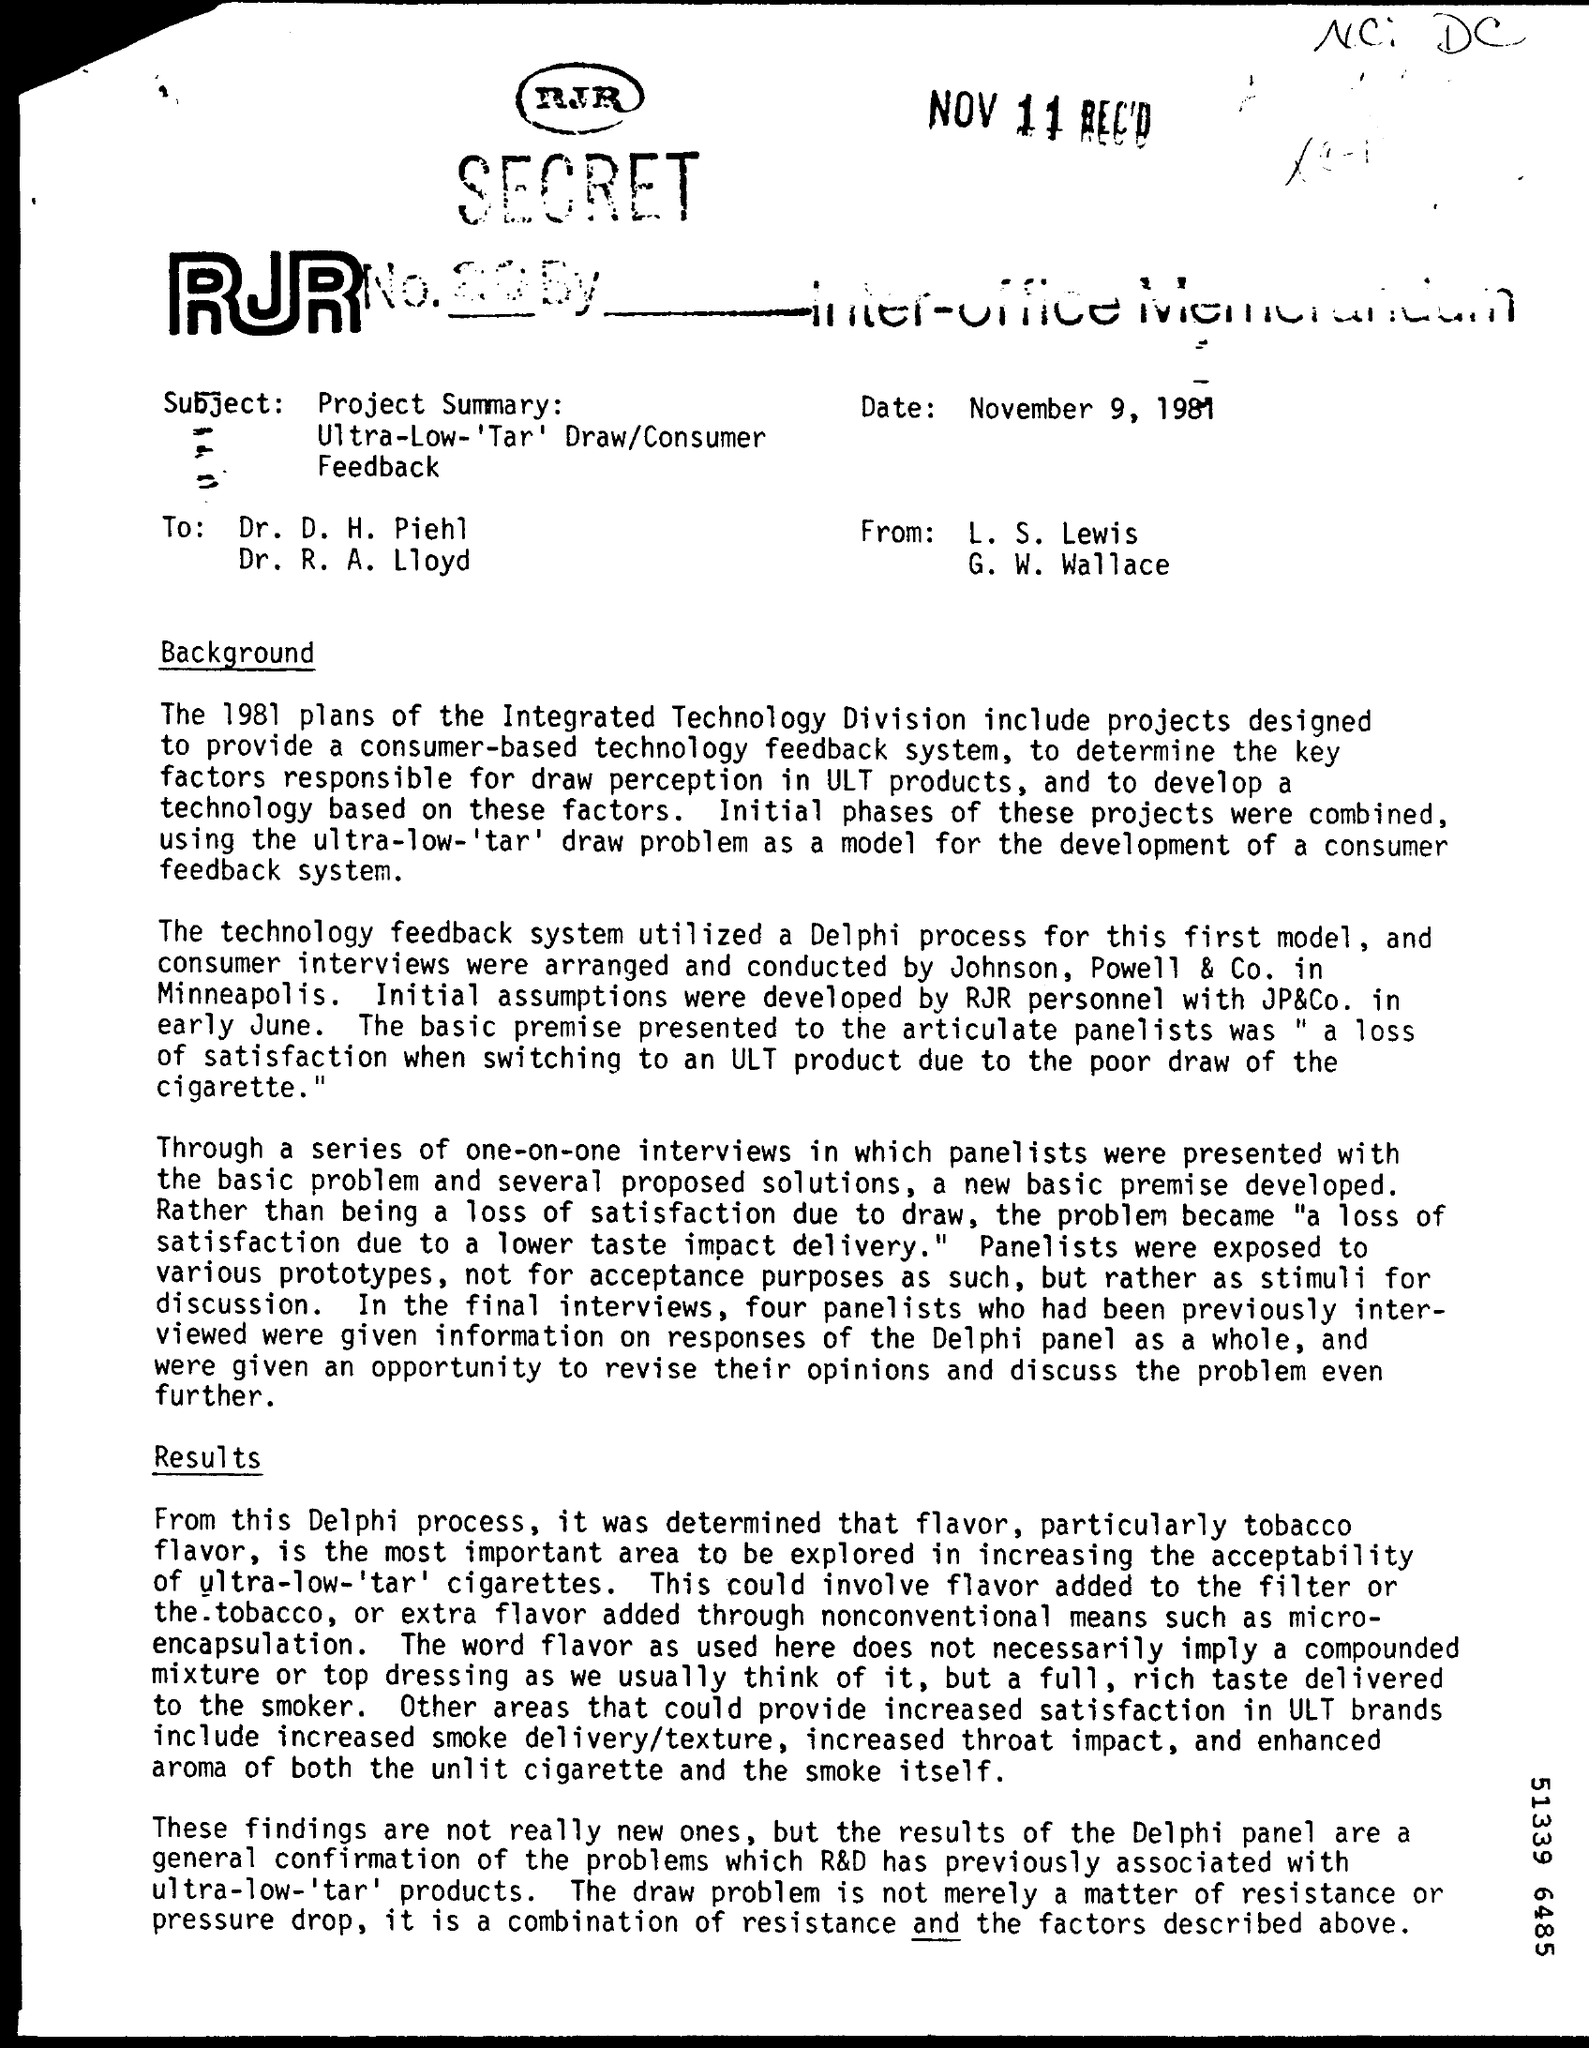What process did the technology feedback system utilize?
Give a very brief answer. Delphi. 